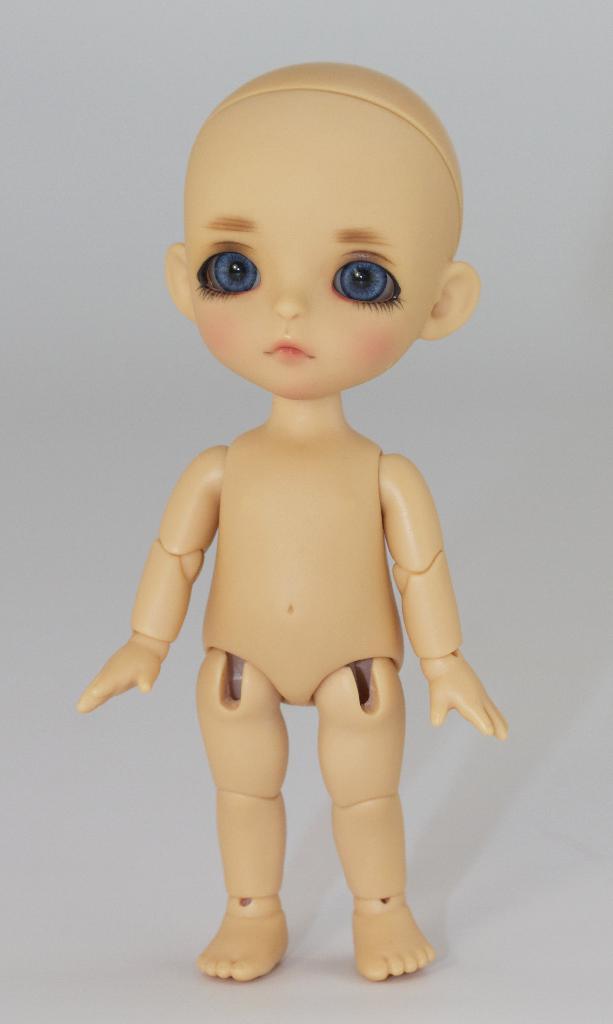In one or two sentences, can you explain what this image depicts? In this image, we can see a toy and there is a white background. 